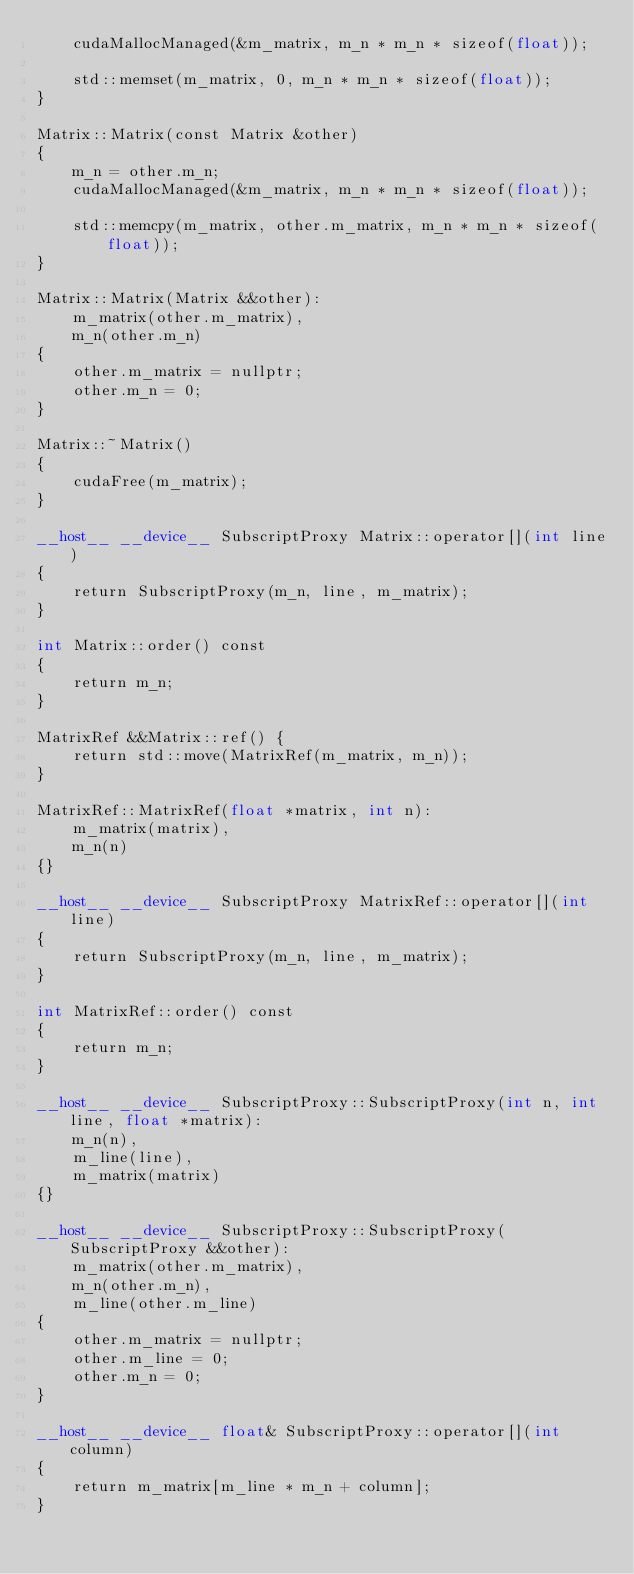<code> <loc_0><loc_0><loc_500><loc_500><_Cuda_>    cudaMallocManaged(&m_matrix, m_n * m_n * sizeof(float));

    std::memset(m_matrix, 0, m_n * m_n * sizeof(float));
}

Matrix::Matrix(const Matrix &other)
{
    m_n = other.m_n;
    cudaMallocManaged(&m_matrix, m_n * m_n * sizeof(float));

    std::memcpy(m_matrix, other.m_matrix, m_n * m_n * sizeof(float));
}

Matrix::Matrix(Matrix &&other):
    m_matrix(other.m_matrix),
    m_n(other.m_n)
{
    other.m_matrix = nullptr;
    other.m_n = 0;
}

Matrix::~Matrix()
{
    cudaFree(m_matrix);
}

__host__ __device__ SubscriptProxy Matrix::operator[](int line)
{
    return SubscriptProxy(m_n, line, m_matrix);
}

int Matrix::order() const
{
    return m_n;
}

MatrixRef &&Matrix::ref() {
    return std::move(MatrixRef(m_matrix, m_n));
}

MatrixRef::MatrixRef(float *matrix, int n):
    m_matrix(matrix),
    m_n(n)
{}

__host__ __device__ SubscriptProxy MatrixRef::operator[](int line)
{
    return SubscriptProxy(m_n, line, m_matrix);
}

int MatrixRef::order() const
{
    return m_n;
}

__host__ __device__ SubscriptProxy::SubscriptProxy(int n, int line, float *matrix):
    m_n(n),
    m_line(line),
    m_matrix(matrix)
{}

__host__ __device__ SubscriptProxy::SubscriptProxy(SubscriptProxy &&other):
    m_matrix(other.m_matrix),
    m_n(other.m_n),
    m_line(other.m_line)
{
    other.m_matrix = nullptr;
    other.m_line = 0;
    other.m_n = 0;
}

__host__ __device__ float& SubscriptProxy::operator[](int column)
{
    return m_matrix[m_line * m_n + column];
}</code> 